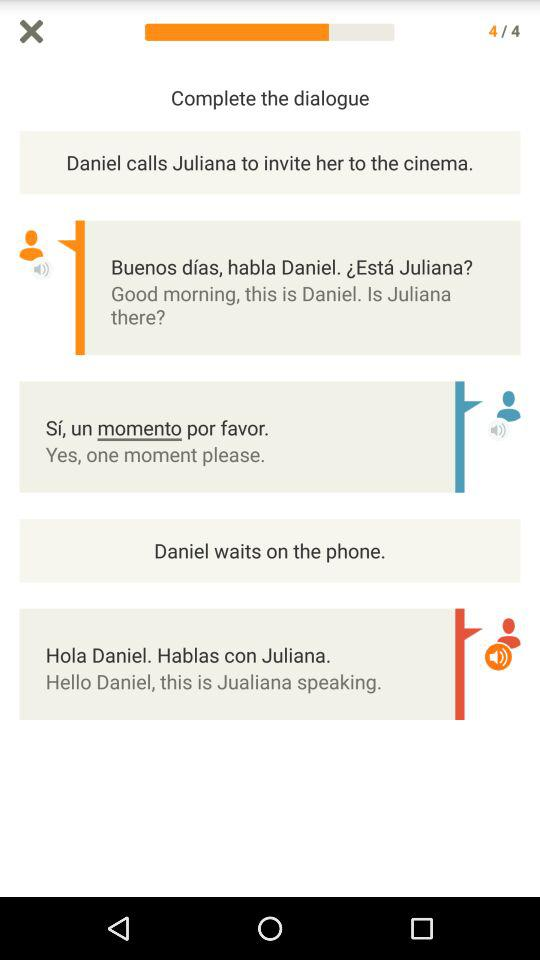How many dialogues are shown here?
When the provided information is insufficient, respond with <no answer>. <no answer> 